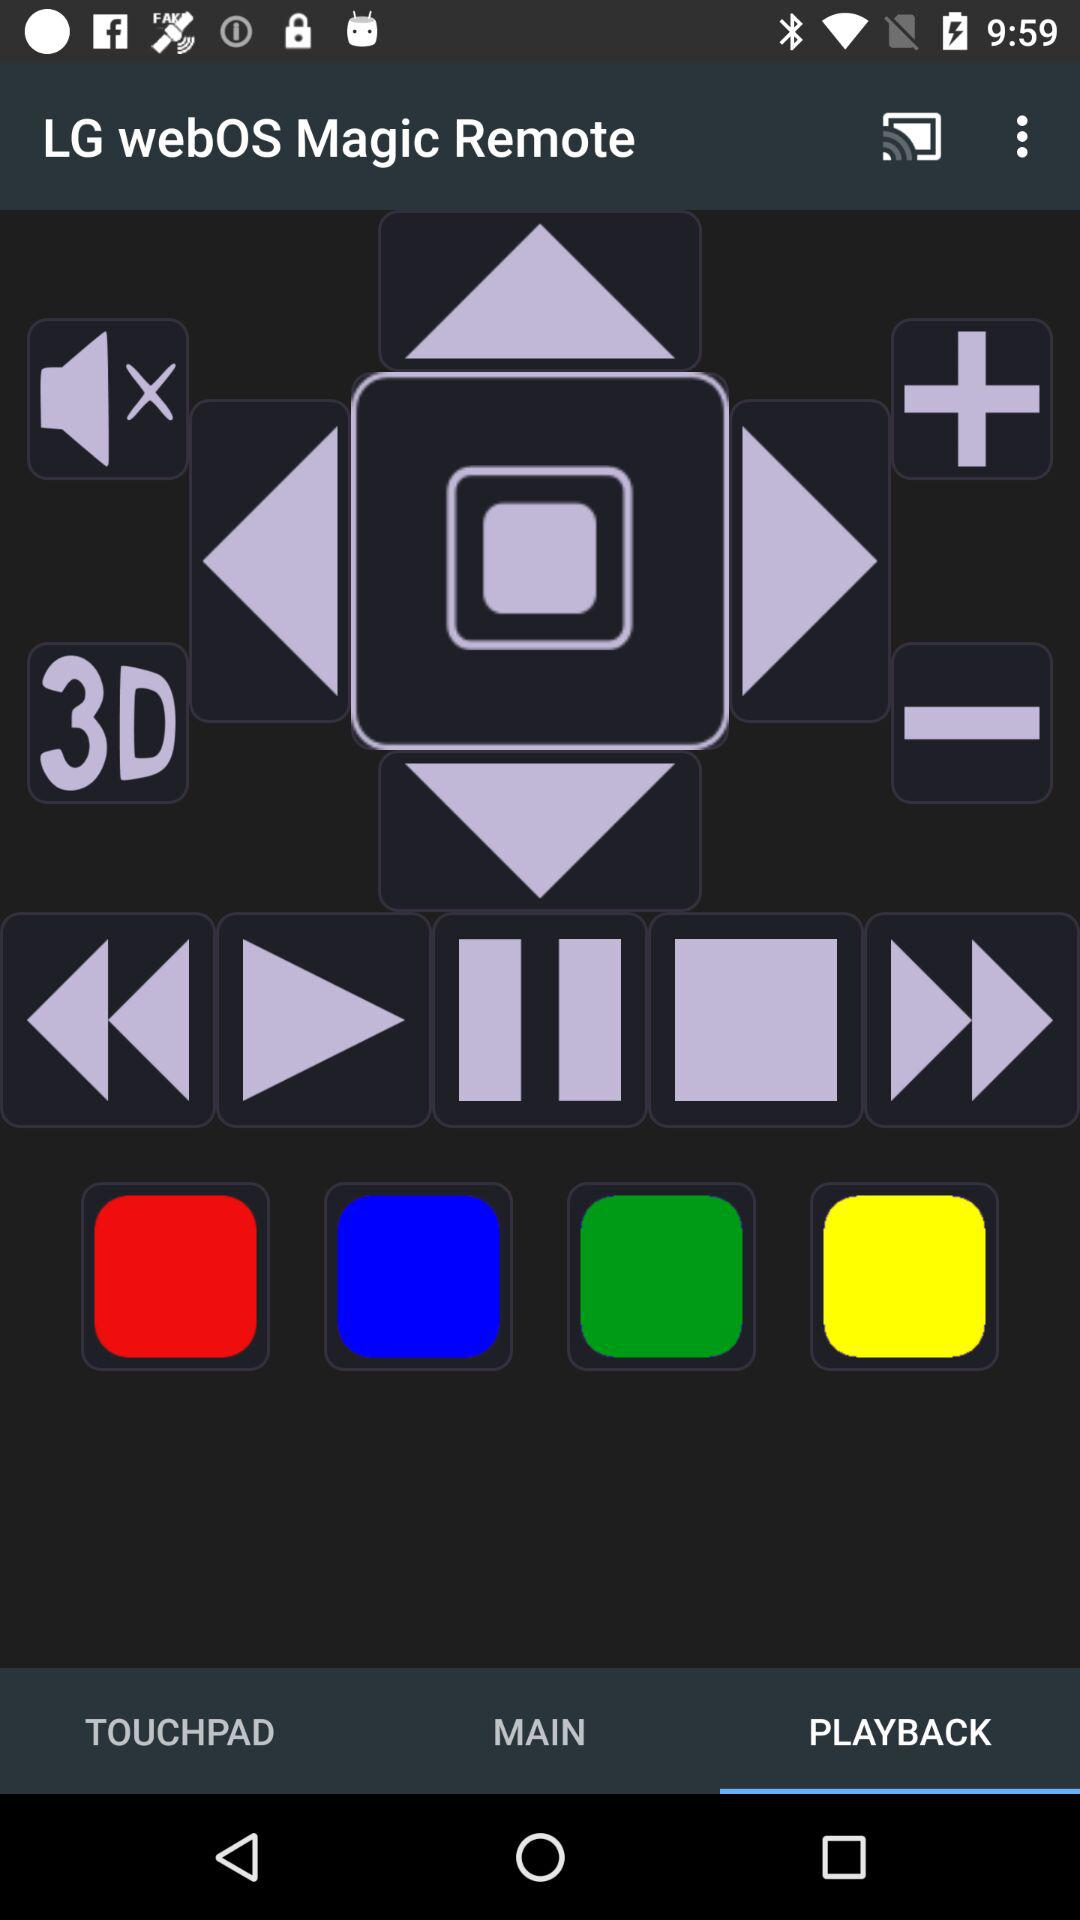What tab is selected? The selected tab is "PLAYBACK". 